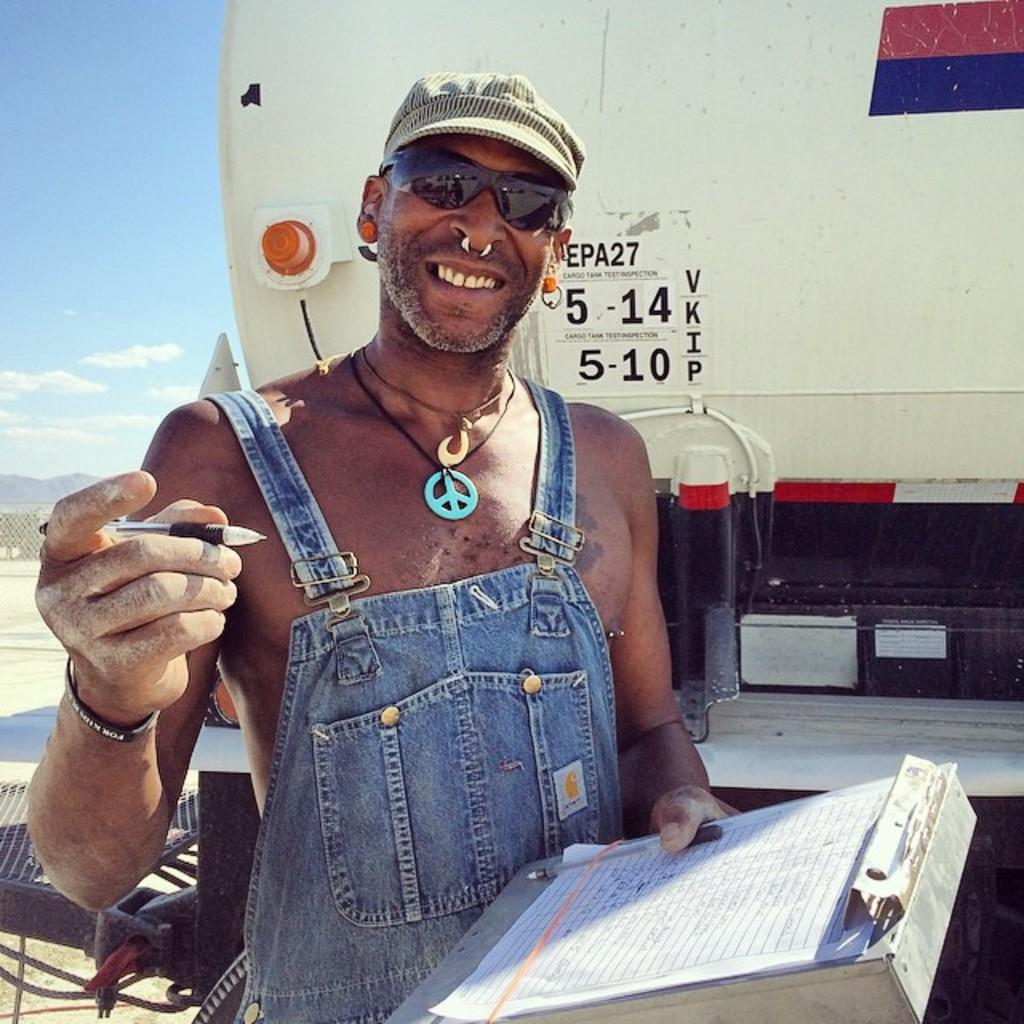What is the man in the image holding? The man is holding a pen in the image. What else can be seen in the image besides the man? There are papers and a pad in the image. What is the man's facial expression? The man is smiling in the image. What can be seen in the background of the image? There is a vehicle and the sky visible in the background of the image. What is the condition of the sky in the image? The sky has clouds in the image. How many straws are present in the image? There are no straws present in the image. What type of quiver can be seen in the image? There is no quiver present in the image. 